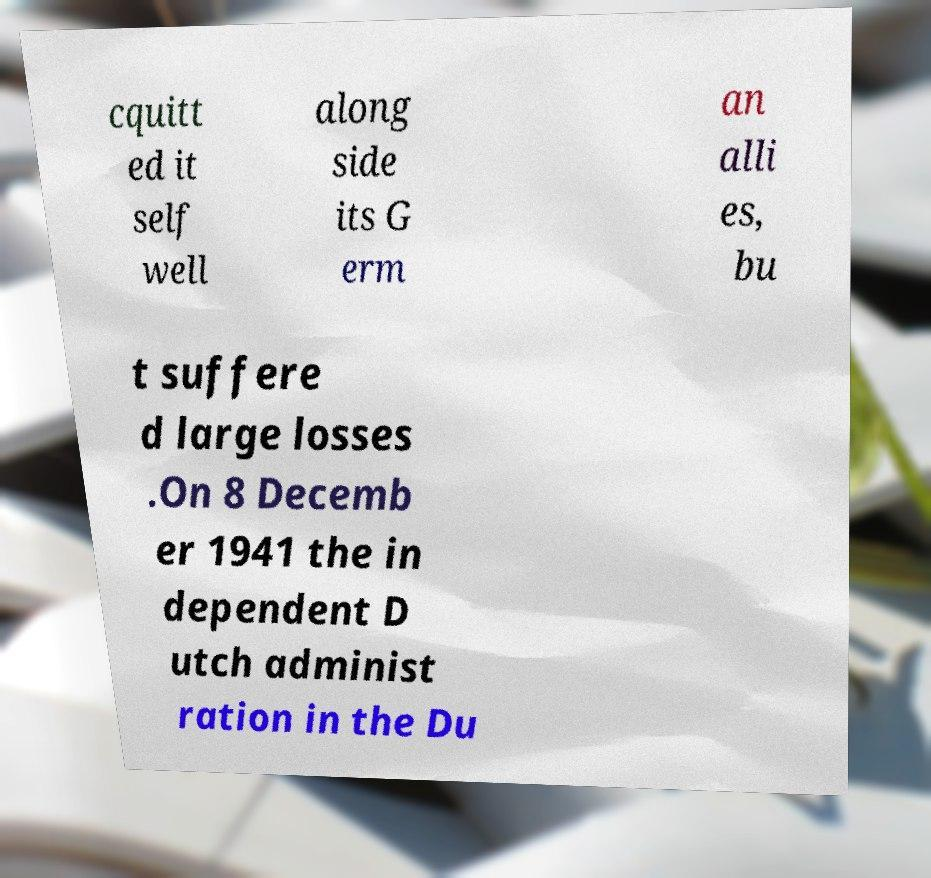There's text embedded in this image that I need extracted. Can you transcribe it verbatim? cquitt ed it self well along side its G erm an alli es, bu t suffere d large losses .On 8 Decemb er 1941 the in dependent D utch administ ration in the Du 